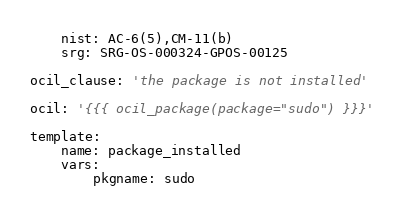<code> <loc_0><loc_0><loc_500><loc_500><_YAML_>    nist: AC-6(5),CM-11(b)
    srg: SRG-OS-000324-GPOS-00125

ocil_clause: 'the package is not installed'

ocil: '{{{ ocil_package(package="sudo") }}}'

template:
    name: package_installed
    vars:
        pkgname: sudo
</code> 